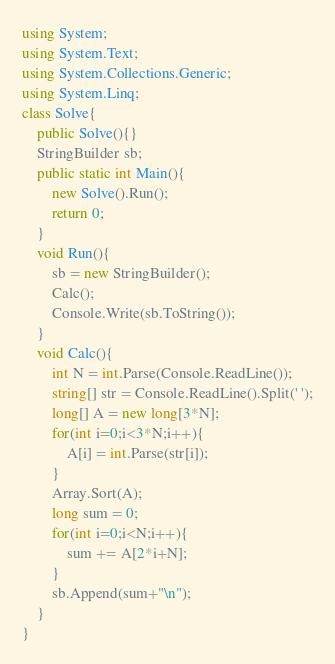Convert code to text. <code><loc_0><loc_0><loc_500><loc_500><_C#_>using System;
using System.Text;
using System.Collections.Generic;
using System.Linq;
class Solve{
    public Solve(){}
    StringBuilder sb;
    public static int Main(){
        new Solve().Run();
        return 0;
    }
    void Run(){
        sb = new StringBuilder();
        Calc();
        Console.Write(sb.ToString());
    }
    void Calc(){
        int N = int.Parse(Console.ReadLine());
        string[] str = Console.ReadLine().Split(' ');
        long[] A = new long[3*N];
        for(int i=0;i<3*N;i++){
            A[i] = int.Parse(str[i]);
        }
        Array.Sort(A);
        long sum = 0;
        for(int i=0;i<N;i++){
            sum += A[2*i+N];
        }
        sb.Append(sum+"\n");
    }
}</code> 